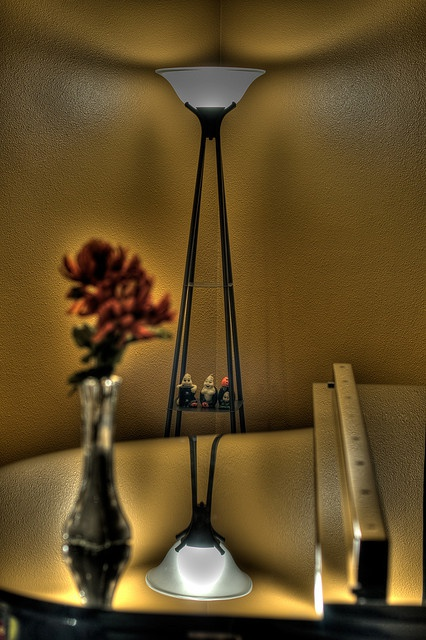Describe the objects in this image and their specific colors. I can see a vase in black, gray, and tan tones in this image. 